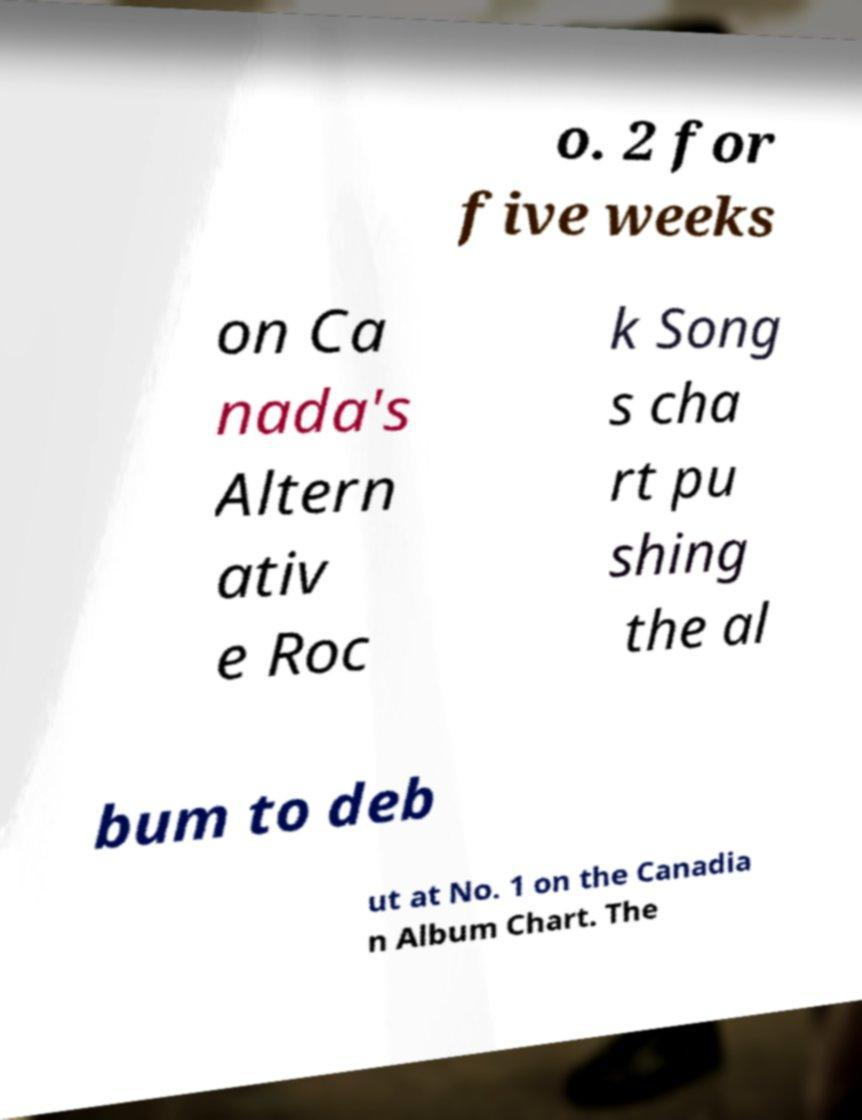There's text embedded in this image that I need extracted. Can you transcribe it verbatim? o. 2 for five weeks on Ca nada's Altern ativ e Roc k Song s cha rt pu shing the al bum to deb ut at No. 1 on the Canadia n Album Chart. The 